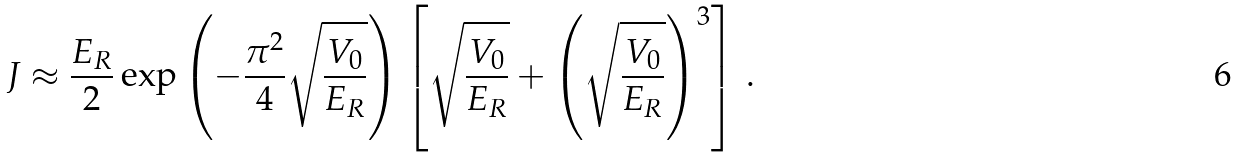Convert formula to latex. <formula><loc_0><loc_0><loc_500><loc_500>J \approx \frac { E _ { R } } { 2 } \exp \left ( - \frac { \pi ^ { 2 } } { 4 } \sqrt { \frac { V _ { 0 } } { E _ { R } } } \right ) \left [ \sqrt { \frac { V _ { 0 } } { E _ { R } } } + \left ( \sqrt { \frac { V _ { 0 } } { E _ { R } } } \right ) ^ { 3 } \right ] \, .</formula> 